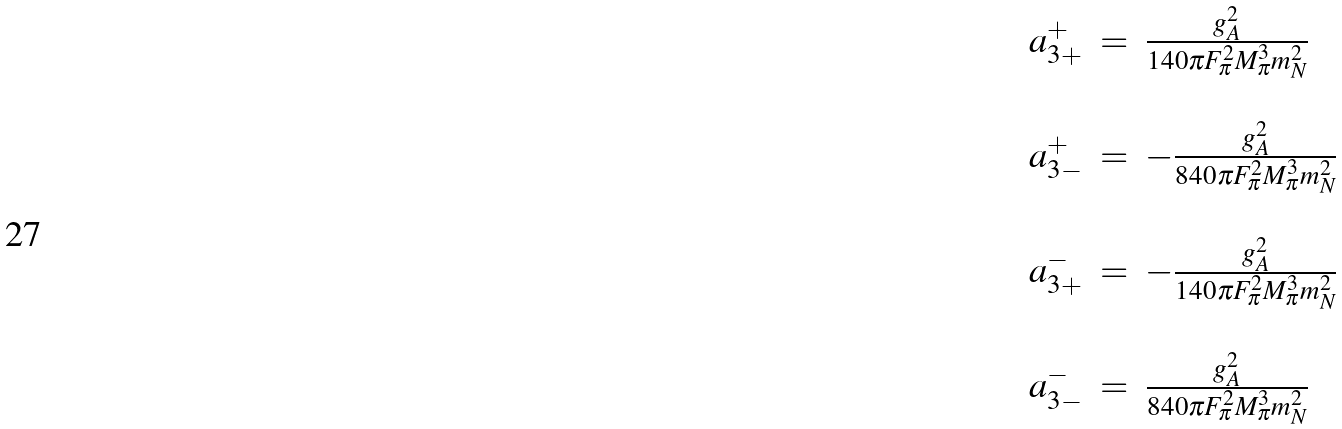<formula> <loc_0><loc_0><loc_500><loc_500>\begin{array} { r c l } a _ { 3 + } ^ { + } & = & \frac { g _ { A } ^ { 2 } } { 1 4 0 \pi F _ { \pi } ^ { 2 } M _ { \pi } ^ { 3 } m _ { N } ^ { 2 } } \\ & & \\ a _ { 3 - } ^ { + } & = & - \frac { g _ { A } ^ { 2 } } { 8 4 0 \pi F _ { \pi } ^ { 2 } M _ { \pi } ^ { 3 } m _ { N } ^ { 2 } } \\ & & \\ a _ { 3 + } ^ { - } & = & - \frac { g _ { A } ^ { 2 } } { 1 4 0 \pi F _ { \pi } ^ { 2 } M _ { \pi } ^ { 3 } m _ { N } ^ { 2 } } \\ & & \\ a _ { 3 - } ^ { - } & = & \frac { g _ { A } ^ { 2 } } { 8 4 0 \pi F _ { \pi } ^ { 2 } M _ { \pi } ^ { 3 } m _ { N } ^ { 2 } } \\ & & \end{array}</formula> 